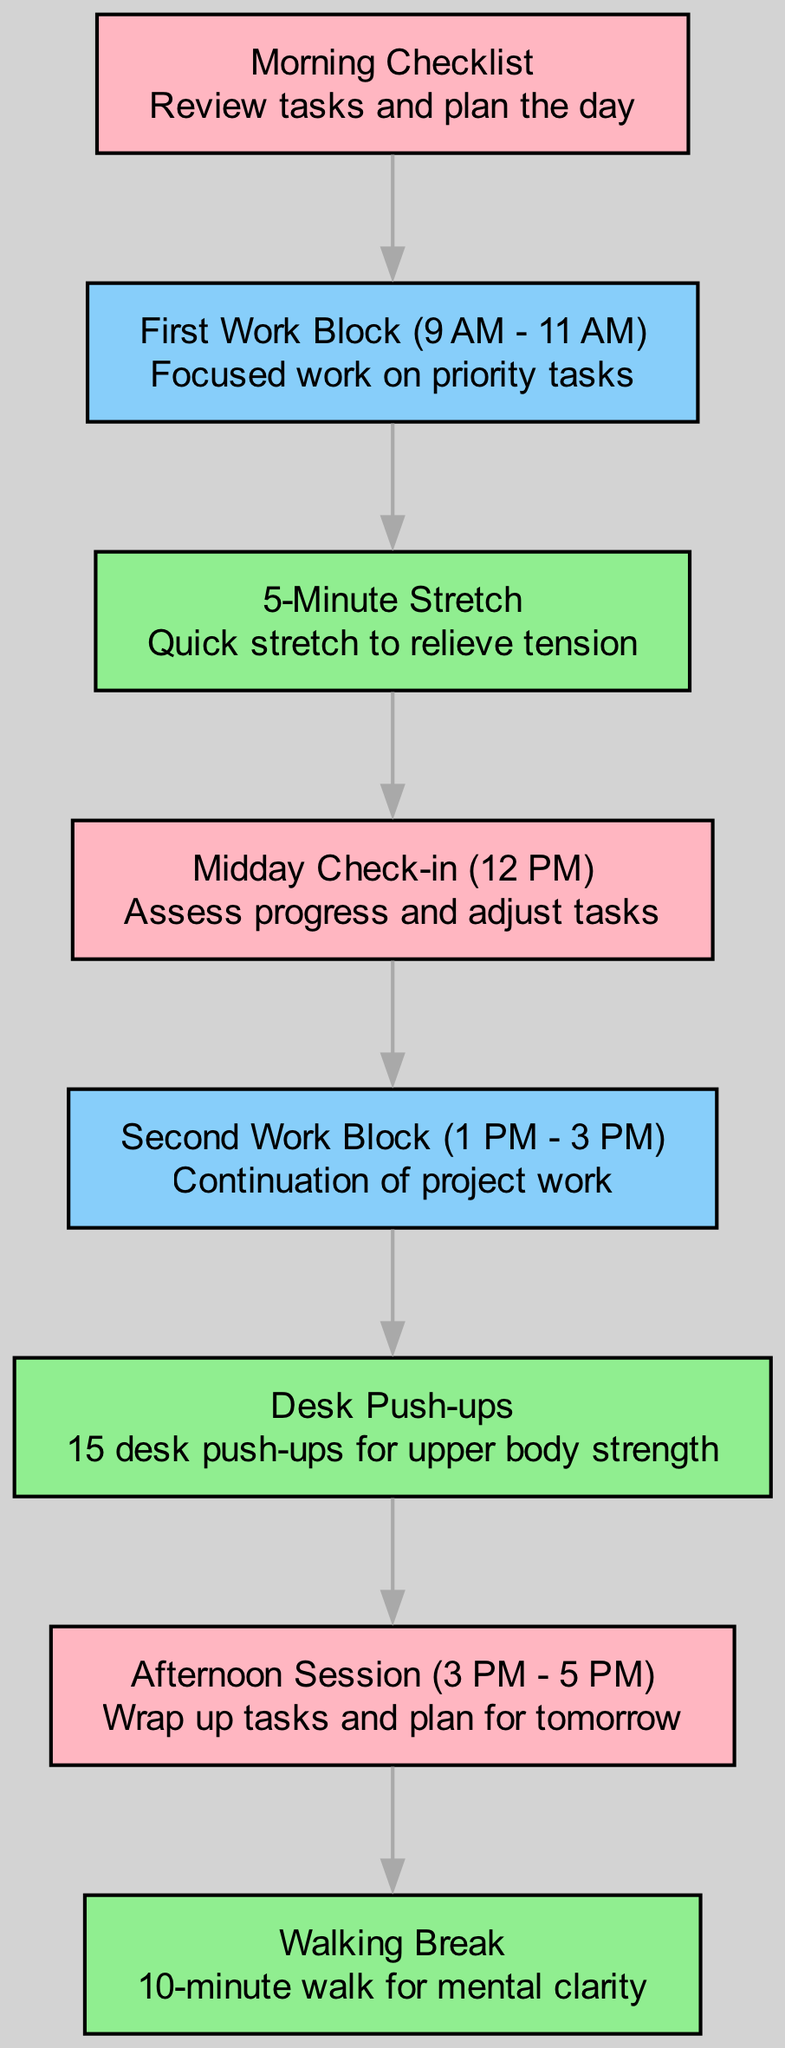What is the first activity in the daily work routine? The first activity is the "Morning Checklist," which is a brief review of tasks and planning for the day. This information is indicated as the starting node in the diagram.
Answer: Morning Checklist How many micro-exercises are included in the routine? There are three micro-exercises listed in the diagram: "5-Minute Stretch," "Desk Push-ups," and "Walking Break." By counting the nodes categorized as micro-exercises, we can determine this.
Answer: 3 What follows the "First Work Block"? The "5-Minute Stretch" follows the "First Work Block," as indicated by the directed edge connecting these two nodes in the diagram.
Answer: 5-Minute Stretch What type of node is "Midday Check-in"? The "Midday Check-in" is an event node that assesses progress and adjusts tasks, which according to the designations in the diagram, is categorized as a key task activity.
Answer: Event What is the last task represented in the daily routine? The last task represented in the daily routine is the "Walking Break," which occurs after the "Afternoon Session," making it the final node in the flow.
Answer: Walking Break What is the relationship between "Second Work Block" and "Desk Push-ups"? The relationship is that the "Desk Push-ups" are performed immediately after the "Second Work Block," as shown by the directed edge connecting these two nodes.
Answer: Desk Push-ups How many edges are present in the diagram? There are six edges present in the diagram, connecting the nodes in a sequential flow of the daily routine. This can be determined by counting the connections drawn between nodes.
Answer: 6 Which micro-exercise is positioned between work blocks? The "Desk Push-ups" micro-exercise is positioned between the "Second Work Block" and the "Afternoon Session" in the routine timeline as the direct follow-up activity.
Answer: Desk Push-ups 